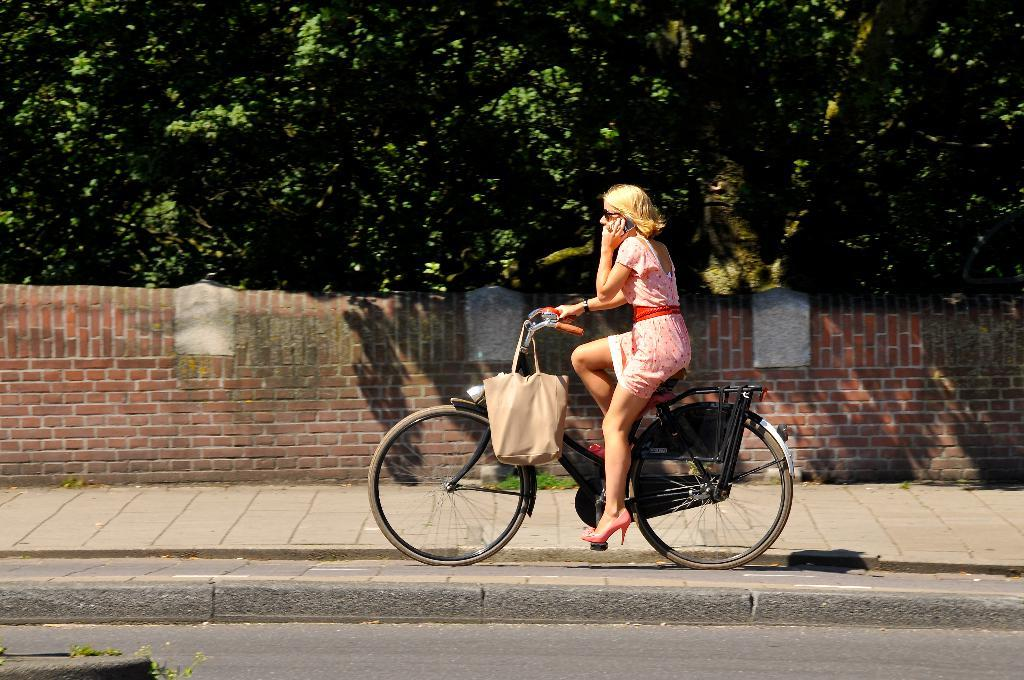Who is the main subject in the image? There is a woman in the image. What is the woman doing in the image? The woman is riding a bicycle and talking on a mobile phone. What can be seen in the background of the image? There are trees and a brick wall in the background of the image. What type of knowledge is the woman sharing with the cub in the image? There is no cub present in the image, and therefore no such interaction can be observed. 